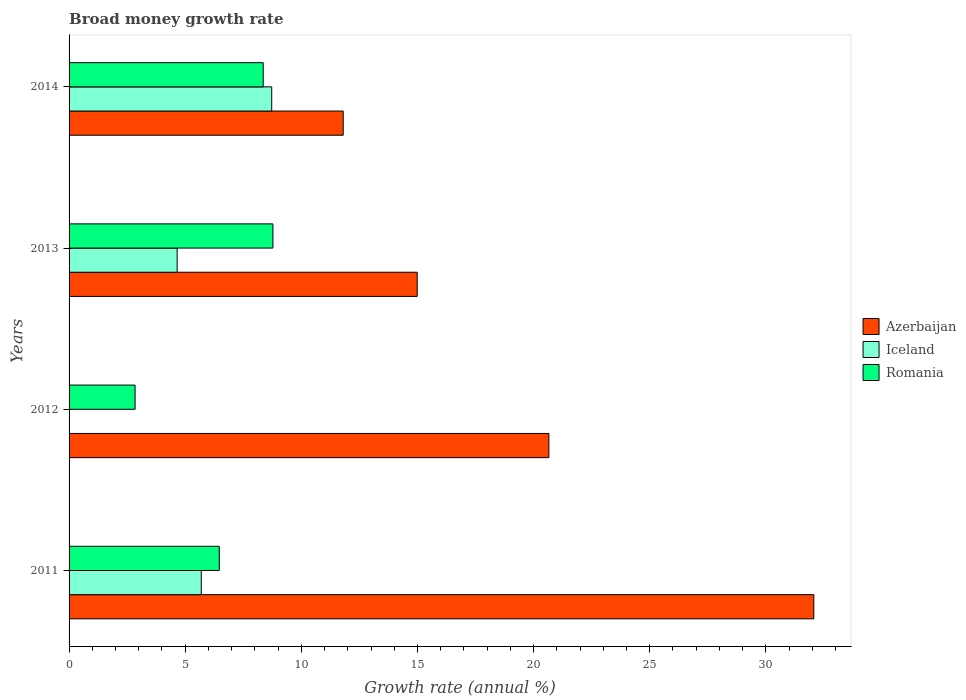How many different coloured bars are there?
Offer a very short reply. 3. Are the number of bars per tick equal to the number of legend labels?
Keep it short and to the point. No. How many bars are there on the 1st tick from the top?
Your answer should be very brief. 3. How many bars are there on the 2nd tick from the bottom?
Ensure brevity in your answer.  2. What is the label of the 4th group of bars from the top?
Provide a short and direct response. 2011. In how many cases, is the number of bars for a given year not equal to the number of legend labels?
Your answer should be compact. 1. What is the growth rate in Iceland in 2012?
Provide a succinct answer. 0. Across all years, what is the maximum growth rate in Romania?
Provide a succinct answer. 8.78. Across all years, what is the minimum growth rate in Iceland?
Your response must be concise. 0. What is the total growth rate in Romania in the graph?
Ensure brevity in your answer.  26.44. What is the difference between the growth rate in Azerbaijan in 2012 and that in 2013?
Ensure brevity in your answer.  5.67. What is the difference between the growth rate in Romania in 2014 and the growth rate in Iceland in 2013?
Your answer should be compact. 3.7. What is the average growth rate in Romania per year?
Your response must be concise. 6.61. In the year 2013, what is the difference between the growth rate in Azerbaijan and growth rate in Romania?
Offer a terse response. 6.21. In how many years, is the growth rate in Iceland greater than 8 %?
Your response must be concise. 1. What is the ratio of the growth rate in Romania in 2011 to that in 2013?
Ensure brevity in your answer.  0.74. What is the difference between the highest and the second highest growth rate in Romania?
Keep it short and to the point. 0.42. What is the difference between the highest and the lowest growth rate in Iceland?
Offer a very short reply. 8.73. Is it the case that in every year, the sum of the growth rate in Romania and growth rate in Azerbaijan is greater than the growth rate in Iceland?
Keep it short and to the point. Yes. What is the difference between two consecutive major ticks on the X-axis?
Keep it short and to the point. 5. Does the graph contain any zero values?
Ensure brevity in your answer.  Yes. Does the graph contain grids?
Your answer should be very brief. No. Where does the legend appear in the graph?
Offer a very short reply. Center right. How many legend labels are there?
Your answer should be compact. 3. How are the legend labels stacked?
Provide a short and direct response. Vertical. What is the title of the graph?
Keep it short and to the point. Broad money growth rate. Does "Belgium" appear as one of the legend labels in the graph?
Your answer should be compact. No. What is the label or title of the X-axis?
Offer a very short reply. Growth rate (annual %). What is the label or title of the Y-axis?
Your response must be concise. Years. What is the Growth rate (annual %) of Azerbaijan in 2011?
Your response must be concise. 32.07. What is the Growth rate (annual %) of Iceland in 2011?
Ensure brevity in your answer.  5.69. What is the Growth rate (annual %) in Romania in 2011?
Keep it short and to the point. 6.47. What is the Growth rate (annual %) of Azerbaijan in 2012?
Offer a terse response. 20.66. What is the Growth rate (annual %) in Iceland in 2012?
Offer a terse response. 0. What is the Growth rate (annual %) in Romania in 2012?
Give a very brief answer. 2.84. What is the Growth rate (annual %) in Azerbaijan in 2013?
Ensure brevity in your answer.  14.99. What is the Growth rate (annual %) in Iceland in 2013?
Make the answer very short. 4.65. What is the Growth rate (annual %) in Romania in 2013?
Offer a very short reply. 8.78. What is the Growth rate (annual %) of Azerbaijan in 2014?
Give a very brief answer. 11.8. What is the Growth rate (annual %) of Iceland in 2014?
Offer a very short reply. 8.73. What is the Growth rate (annual %) in Romania in 2014?
Offer a terse response. 8.36. Across all years, what is the maximum Growth rate (annual %) in Azerbaijan?
Provide a short and direct response. 32.07. Across all years, what is the maximum Growth rate (annual %) of Iceland?
Your answer should be very brief. 8.73. Across all years, what is the maximum Growth rate (annual %) of Romania?
Make the answer very short. 8.78. Across all years, what is the minimum Growth rate (annual %) of Azerbaijan?
Provide a short and direct response. 11.8. Across all years, what is the minimum Growth rate (annual %) in Iceland?
Give a very brief answer. 0. Across all years, what is the minimum Growth rate (annual %) in Romania?
Keep it short and to the point. 2.84. What is the total Growth rate (annual %) of Azerbaijan in the graph?
Ensure brevity in your answer.  79.52. What is the total Growth rate (annual %) in Iceland in the graph?
Give a very brief answer. 19.07. What is the total Growth rate (annual %) of Romania in the graph?
Give a very brief answer. 26.44. What is the difference between the Growth rate (annual %) in Azerbaijan in 2011 and that in 2012?
Provide a succinct answer. 11.41. What is the difference between the Growth rate (annual %) of Romania in 2011 and that in 2012?
Keep it short and to the point. 3.62. What is the difference between the Growth rate (annual %) in Azerbaijan in 2011 and that in 2013?
Keep it short and to the point. 17.08. What is the difference between the Growth rate (annual %) of Iceland in 2011 and that in 2013?
Make the answer very short. 1.04. What is the difference between the Growth rate (annual %) of Romania in 2011 and that in 2013?
Your response must be concise. -2.31. What is the difference between the Growth rate (annual %) of Azerbaijan in 2011 and that in 2014?
Provide a short and direct response. 20.26. What is the difference between the Growth rate (annual %) in Iceland in 2011 and that in 2014?
Ensure brevity in your answer.  -3.03. What is the difference between the Growth rate (annual %) in Romania in 2011 and that in 2014?
Make the answer very short. -1.89. What is the difference between the Growth rate (annual %) of Azerbaijan in 2012 and that in 2013?
Give a very brief answer. 5.67. What is the difference between the Growth rate (annual %) in Romania in 2012 and that in 2013?
Make the answer very short. -5.93. What is the difference between the Growth rate (annual %) of Azerbaijan in 2012 and that in 2014?
Make the answer very short. 8.86. What is the difference between the Growth rate (annual %) in Romania in 2012 and that in 2014?
Offer a very short reply. -5.52. What is the difference between the Growth rate (annual %) in Azerbaijan in 2013 and that in 2014?
Offer a very short reply. 3.19. What is the difference between the Growth rate (annual %) in Iceland in 2013 and that in 2014?
Provide a succinct answer. -4.07. What is the difference between the Growth rate (annual %) of Romania in 2013 and that in 2014?
Provide a succinct answer. 0.42. What is the difference between the Growth rate (annual %) of Azerbaijan in 2011 and the Growth rate (annual %) of Romania in 2012?
Ensure brevity in your answer.  29.22. What is the difference between the Growth rate (annual %) in Iceland in 2011 and the Growth rate (annual %) in Romania in 2012?
Provide a short and direct response. 2.85. What is the difference between the Growth rate (annual %) of Azerbaijan in 2011 and the Growth rate (annual %) of Iceland in 2013?
Your response must be concise. 27.41. What is the difference between the Growth rate (annual %) in Azerbaijan in 2011 and the Growth rate (annual %) in Romania in 2013?
Provide a short and direct response. 23.29. What is the difference between the Growth rate (annual %) of Iceland in 2011 and the Growth rate (annual %) of Romania in 2013?
Make the answer very short. -3.08. What is the difference between the Growth rate (annual %) in Azerbaijan in 2011 and the Growth rate (annual %) in Iceland in 2014?
Make the answer very short. 23.34. What is the difference between the Growth rate (annual %) in Azerbaijan in 2011 and the Growth rate (annual %) in Romania in 2014?
Keep it short and to the point. 23.71. What is the difference between the Growth rate (annual %) of Iceland in 2011 and the Growth rate (annual %) of Romania in 2014?
Your response must be concise. -2.67. What is the difference between the Growth rate (annual %) in Azerbaijan in 2012 and the Growth rate (annual %) in Iceland in 2013?
Your response must be concise. 16. What is the difference between the Growth rate (annual %) in Azerbaijan in 2012 and the Growth rate (annual %) in Romania in 2013?
Your answer should be very brief. 11.88. What is the difference between the Growth rate (annual %) of Azerbaijan in 2012 and the Growth rate (annual %) of Iceland in 2014?
Ensure brevity in your answer.  11.93. What is the difference between the Growth rate (annual %) in Azerbaijan in 2012 and the Growth rate (annual %) in Romania in 2014?
Offer a terse response. 12.3. What is the difference between the Growth rate (annual %) of Azerbaijan in 2013 and the Growth rate (annual %) of Iceland in 2014?
Keep it short and to the point. 6.26. What is the difference between the Growth rate (annual %) of Azerbaijan in 2013 and the Growth rate (annual %) of Romania in 2014?
Ensure brevity in your answer.  6.63. What is the difference between the Growth rate (annual %) in Iceland in 2013 and the Growth rate (annual %) in Romania in 2014?
Your answer should be very brief. -3.7. What is the average Growth rate (annual %) of Azerbaijan per year?
Give a very brief answer. 19.88. What is the average Growth rate (annual %) of Iceland per year?
Your answer should be very brief. 4.77. What is the average Growth rate (annual %) in Romania per year?
Ensure brevity in your answer.  6.61. In the year 2011, what is the difference between the Growth rate (annual %) in Azerbaijan and Growth rate (annual %) in Iceland?
Make the answer very short. 26.37. In the year 2011, what is the difference between the Growth rate (annual %) in Azerbaijan and Growth rate (annual %) in Romania?
Ensure brevity in your answer.  25.6. In the year 2011, what is the difference between the Growth rate (annual %) in Iceland and Growth rate (annual %) in Romania?
Ensure brevity in your answer.  -0.77. In the year 2012, what is the difference between the Growth rate (annual %) of Azerbaijan and Growth rate (annual %) of Romania?
Keep it short and to the point. 17.82. In the year 2013, what is the difference between the Growth rate (annual %) in Azerbaijan and Growth rate (annual %) in Iceland?
Provide a succinct answer. 10.34. In the year 2013, what is the difference between the Growth rate (annual %) of Azerbaijan and Growth rate (annual %) of Romania?
Ensure brevity in your answer.  6.21. In the year 2013, what is the difference between the Growth rate (annual %) of Iceland and Growth rate (annual %) of Romania?
Your answer should be compact. -4.12. In the year 2014, what is the difference between the Growth rate (annual %) in Azerbaijan and Growth rate (annual %) in Iceland?
Offer a terse response. 3.08. In the year 2014, what is the difference between the Growth rate (annual %) in Azerbaijan and Growth rate (annual %) in Romania?
Provide a succinct answer. 3.44. In the year 2014, what is the difference between the Growth rate (annual %) of Iceland and Growth rate (annual %) of Romania?
Your response must be concise. 0.37. What is the ratio of the Growth rate (annual %) in Azerbaijan in 2011 to that in 2012?
Offer a very short reply. 1.55. What is the ratio of the Growth rate (annual %) of Romania in 2011 to that in 2012?
Make the answer very short. 2.28. What is the ratio of the Growth rate (annual %) in Azerbaijan in 2011 to that in 2013?
Provide a succinct answer. 2.14. What is the ratio of the Growth rate (annual %) of Iceland in 2011 to that in 2013?
Ensure brevity in your answer.  1.22. What is the ratio of the Growth rate (annual %) of Romania in 2011 to that in 2013?
Ensure brevity in your answer.  0.74. What is the ratio of the Growth rate (annual %) of Azerbaijan in 2011 to that in 2014?
Provide a short and direct response. 2.72. What is the ratio of the Growth rate (annual %) of Iceland in 2011 to that in 2014?
Offer a terse response. 0.65. What is the ratio of the Growth rate (annual %) of Romania in 2011 to that in 2014?
Make the answer very short. 0.77. What is the ratio of the Growth rate (annual %) of Azerbaijan in 2012 to that in 2013?
Offer a very short reply. 1.38. What is the ratio of the Growth rate (annual %) of Romania in 2012 to that in 2013?
Make the answer very short. 0.32. What is the ratio of the Growth rate (annual %) of Azerbaijan in 2012 to that in 2014?
Make the answer very short. 1.75. What is the ratio of the Growth rate (annual %) in Romania in 2012 to that in 2014?
Your response must be concise. 0.34. What is the ratio of the Growth rate (annual %) of Azerbaijan in 2013 to that in 2014?
Provide a short and direct response. 1.27. What is the ratio of the Growth rate (annual %) of Iceland in 2013 to that in 2014?
Your answer should be compact. 0.53. What is the ratio of the Growth rate (annual %) of Romania in 2013 to that in 2014?
Make the answer very short. 1.05. What is the difference between the highest and the second highest Growth rate (annual %) in Azerbaijan?
Give a very brief answer. 11.41. What is the difference between the highest and the second highest Growth rate (annual %) of Iceland?
Your response must be concise. 3.03. What is the difference between the highest and the second highest Growth rate (annual %) in Romania?
Provide a succinct answer. 0.42. What is the difference between the highest and the lowest Growth rate (annual %) in Azerbaijan?
Provide a short and direct response. 20.26. What is the difference between the highest and the lowest Growth rate (annual %) of Iceland?
Make the answer very short. 8.73. What is the difference between the highest and the lowest Growth rate (annual %) of Romania?
Keep it short and to the point. 5.93. 